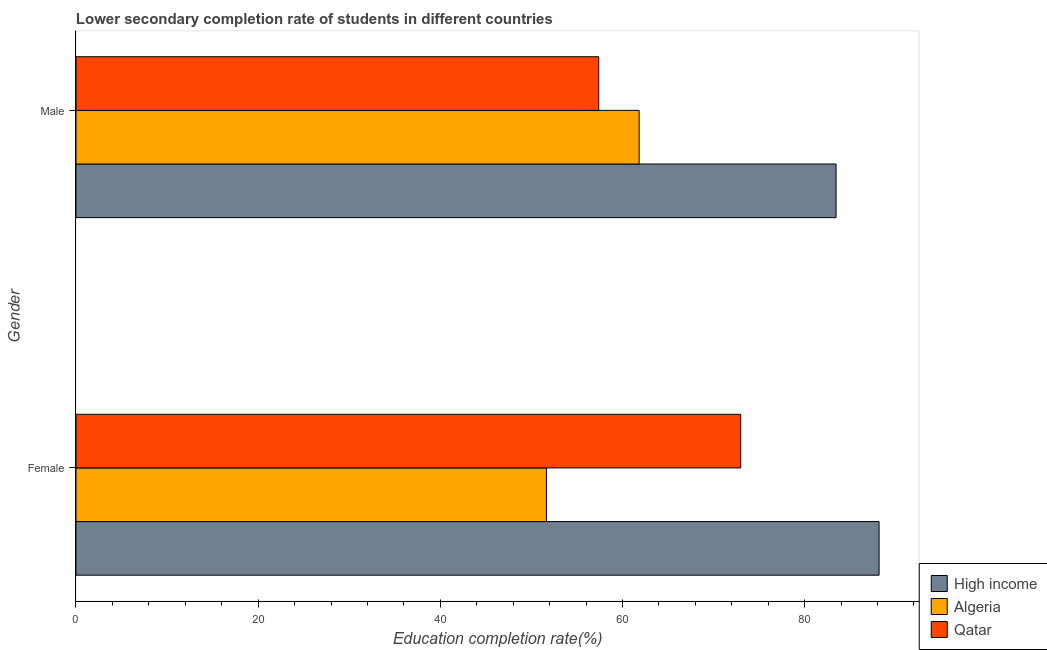How many different coloured bars are there?
Keep it short and to the point. 3. How many bars are there on the 1st tick from the top?
Your answer should be very brief. 3. What is the education completion rate of female students in High income?
Provide a short and direct response. 88.18. Across all countries, what is the maximum education completion rate of female students?
Offer a terse response. 88.18. Across all countries, what is the minimum education completion rate of female students?
Ensure brevity in your answer.  51.66. In which country was the education completion rate of male students maximum?
Offer a terse response. High income. In which country was the education completion rate of male students minimum?
Provide a short and direct response. Qatar. What is the total education completion rate of female students in the graph?
Offer a terse response. 212.82. What is the difference between the education completion rate of female students in Qatar and that in Algeria?
Give a very brief answer. 21.33. What is the difference between the education completion rate of male students in Algeria and the education completion rate of female students in Qatar?
Keep it short and to the point. -11.15. What is the average education completion rate of male students per country?
Keep it short and to the point. 67.56. What is the difference between the education completion rate of male students and education completion rate of female students in Algeria?
Your response must be concise. 10.18. What is the ratio of the education completion rate of female students in High income to that in Qatar?
Your answer should be compact. 1.21. In how many countries, is the education completion rate of female students greater than the average education completion rate of female students taken over all countries?
Provide a succinct answer. 2. What does the 2nd bar from the top in Female represents?
Your response must be concise. Algeria. What does the 3rd bar from the bottom in Female represents?
Your response must be concise. Qatar. How many bars are there?
Your answer should be compact. 6. Are all the bars in the graph horizontal?
Make the answer very short. Yes. How many countries are there in the graph?
Offer a very short reply. 3. What is the difference between two consecutive major ticks on the X-axis?
Keep it short and to the point. 20. Are the values on the major ticks of X-axis written in scientific E-notation?
Give a very brief answer. No. Does the graph contain any zero values?
Your answer should be very brief. No. How many legend labels are there?
Provide a succinct answer. 3. What is the title of the graph?
Your response must be concise. Lower secondary completion rate of students in different countries. What is the label or title of the X-axis?
Your answer should be compact. Education completion rate(%). What is the Education completion rate(%) of High income in Female?
Give a very brief answer. 88.18. What is the Education completion rate(%) of Algeria in Female?
Your response must be concise. 51.66. What is the Education completion rate(%) of Qatar in Female?
Your answer should be compact. 72.99. What is the Education completion rate(%) in High income in Male?
Ensure brevity in your answer.  83.46. What is the Education completion rate(%) of Algeria in Male?
Your answer should be very brief. 61.83. What is the Education completion rate(%) of Qatar in Male?
Ensure brevity in your answer.  57.4. Across all Gender, what is the maximum Education completion rate(%) of High income?
Make the answer very short. 88.18. Across all Gender, what is the maximum Education completion rate(%) in Algeria?
Keep it short and to the point. 61.83. Across all Gender, what is the maximum Education completion rate(%) in Qatar?
Make the answer very short. 72.99. Across all Gender, what is the minimum Education completion rate(%) of High income?
Provide a succinct answer. 83.46. Across all Gender, what is the minimum Education completion rate(%) of Algeria?
Your response must be concise. 51.66. Across all Gender, what is the minimum Education completion rate(%) of Qatar?
Make the answer very short. 57.4. What is the total Education completion rate(%) in High income in the graph?
Keep it short and to the point. 171.64. What is the total Education completion rate(%) in Algeria in the graph?
Your answer should be very brief. 113.49. What is the total Education completion rate(%) in Qatar in the graph?
Offer a very short reply. 130.39. What is the difference between the Education completion rate(%) in High income in Female and that in Male?
Give a very brief answer. 4.72. What is the difference between the Education completion rate(%) of Algeria in Female and that in Male?
Give a very brief answer. -10.18. What is the difference between the Education completion rate(%) in Qatar in Female and that in Male?
Offer a very short reply. 15.59. What is the difference between the Education completion rate(%) in High income in Female and the Education completion rate(%) in Algeria in Male?
Keep it short and to the point. 26.35. What is the difference between the Education completion rate(%) of High income in Female and the Education completion rate(%) of Qatar in Male?
Make the answer very short. 30.78. What is the difference between the Education completion rate(%) in Algeria in Female and the Education completion rate(%) in Qatar in Male?
Give a very brief answer. -5.74. What is the average Education completion rate(%) in High income per Gender?
Provide a succinct answer. 85.82. What is the average Education completion rate(%) of Algeria per Gender?
Give a very brief answer. 56.75. What is the average Education completion rate(%) in Qatar per Gender?
Your answer should be compact. 65.19. What is the difference between the Education completion rate(%) in High income and Education completion rate(%) in Algeria in Female?
Keep it short and to the point. 36.52. What is the difference between the Education completion rate(%) of High income and Education completion rate(%) of Qatar in Female?
Provide a succinct answer. 15.19. What is the difference between the Education completion rate(%) of Algeria and Education completion rate(%) of Qatar in Female?
Your response must be concise. -21.33. What is the difference between the Education completion rate(%) of High income and Education completion rate(%) of Algeria in Male?
Provide a succinct answer. 21.62. What is the difference between the Education completion rate(%) of High income and Education completion rate(%) of Qatar in Male?
Offer a terse response. 26.06. What is the difference between the Education completion rate(%) of Algeria and Education completion rate(%) of Qatar in Male?
Your answer should be very brief. 4.44. What is the ratio of the Education completion rate(%) in High income in Female to that in Male?
Offer a very short reply. 1.06. What is the ratio of the Education completion rate(%) of Algeria in Female to that in Male?
Provide a succinct answer. 0.84. What is the ratio of the Education completion rate(%) of Qatar in Female to that in Male?
Offer a terse response. 1.27. What is the difference between the highest and the second highest Education completion rate(%) in High income?
Provide a short and direct response. 4.72. What is the difference between the highest and the second highest Education completion rate(%) in Algeria?
Keep it short and to the point. 10.18. What is the difference between the highest and the second highest Education completion rate(%) of Qatar?
Provide a short and direct response. 15.59. What is the difference between the highest and the lowest Education completion rate(%) in High income?
Give a very brief answer. 4.72. What is the difference between the highest and the lowest Education completion rate(%) in Algeria?
Keep it short and to the point. 10.18. What is the difference between the highest and the lowest Education completion rate(%) in Qatar?
Make the answer very short. 15.59. 